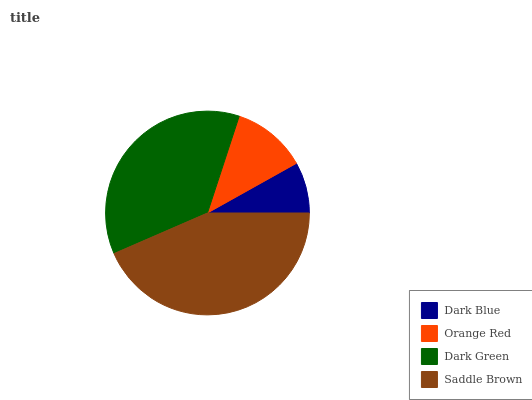Is Dark Blue the minimum?
Answer yes or no. Yes. Is Saddle Brown the maximum?
Answer yes or no. Yes. Is Orange Red the minimum?
Answer yes or no. No. Is Orange Red the maximum?
Answer yes or no. No. Is Orange Red greater than Dark Blue?
Answer yes or no. Yes. Is Dark Blue less than Orange Red?
Answer yes or no. Yes. Is Dark Blue greater than Orange Red?
Answer yes or no. No. Is Orange Red less than Dark Blue?
Answer yes or no. No. Is Dark Green the high median?
Answer yes or no. Yes. Is Orange Red the low median?
Answer yes or no. Yes. Is Dark Blue the high median?
Answer yes or no. No. Is Saddle Brown the low median?
Answer yes or no. No. 